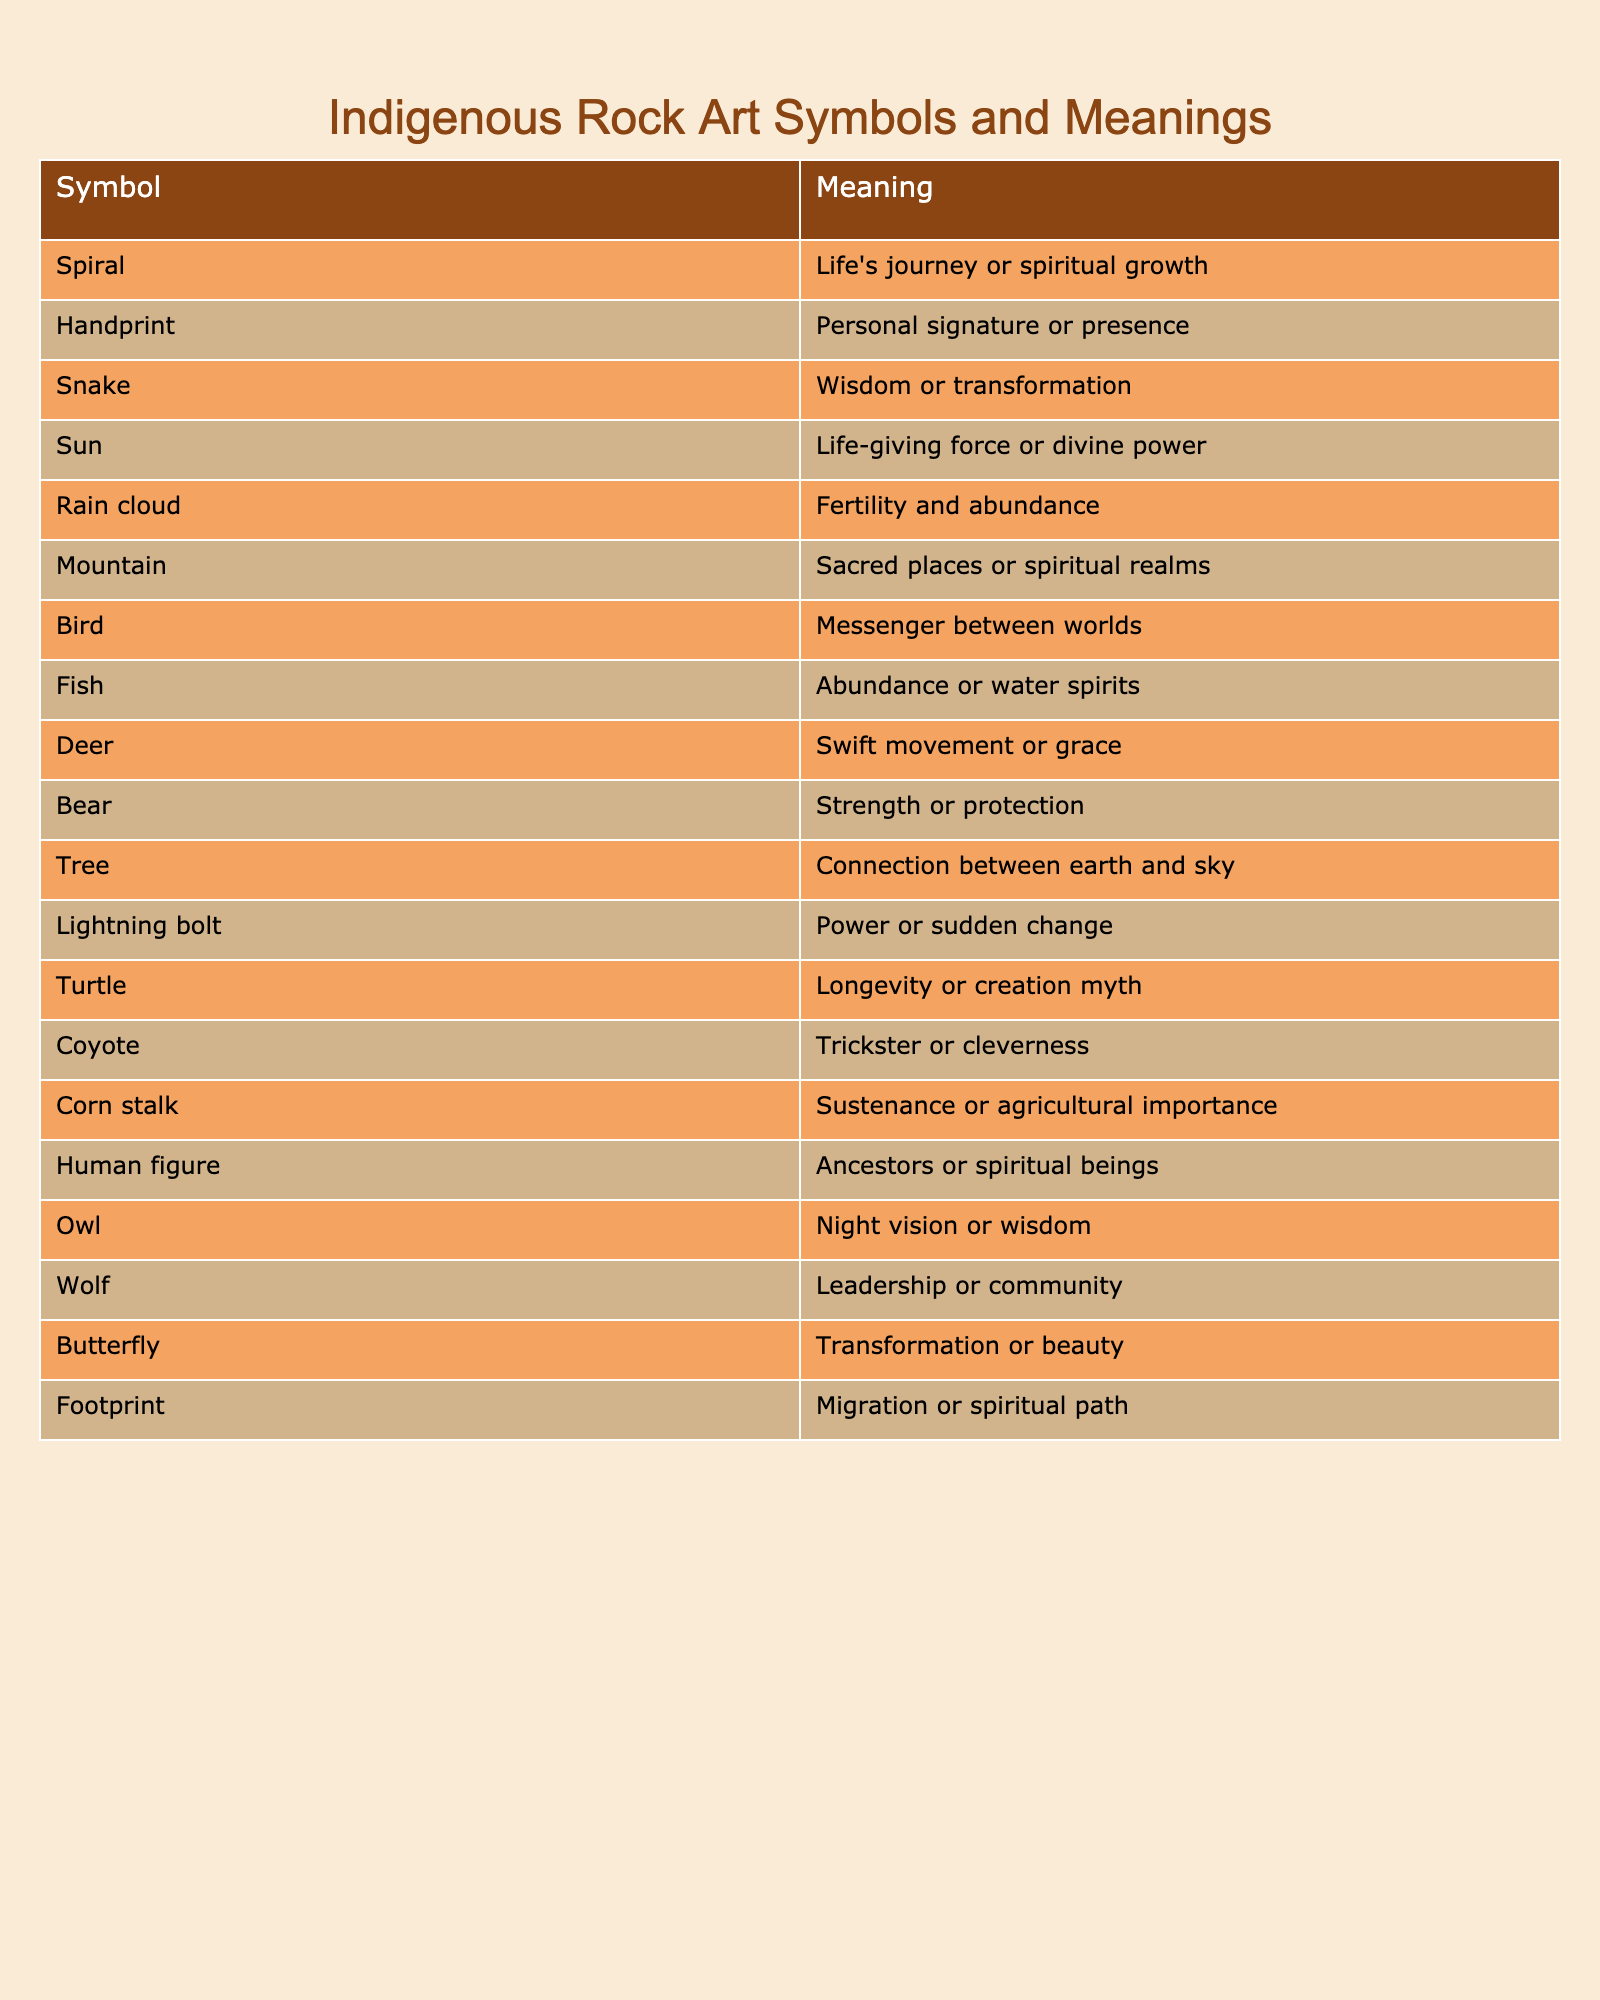What does the spiral symbolize in indigenous rock art? The table states that the spiral represents life's journey or spiritual growth. This is a direct retrieval from the symbol's meaning provided in the table.
Answer: Life's journey or spiritual growth What represents strength in the listed symbols? According to the table, the bear symbolizes strength or protection, and it can be found directly by looking at the symbols in the table.
Answer: Bear Is the handprint associated with personal expression? The table indicates that the handprint represents a personal signature or presence. Thus, the statement can be confirmed as true from the meaning.
Answer: Yes How many symbols in the table are related to transformation? The symbols related to transformation are the snake and the butterfly. Both meanings directly indicate transformation, which gives a total of two symbols.
Answer: 2 Which symbol represents a messenger between worlds? The table shows that the bird is recognized as a messenger between worlds, which can be easily identified through the symbols listed.
Answer: Bird Does the table show that the tree represents a connection between various realms? The meaning provided for the tree indicates it represents connection between earth and sky, confirming that it does symbolize a connection.
Answer: Yes What is the combined significance of the deer and the wolf? The deer represents swift movement or grace, and the wolf symbolizes leadership or community. Thus, when combined, they signify not only grace and movement but also the importance of community and leadership in indigenous beliefs.
Answer: Swift movement, grace, leadership, community Which symbol signifies abundance and also relates to water spirits? The table specifies that the fish symbolizes abundance or water spirits, allowing for a straightforward answer.
Answer: Fish Among all the symbols, which one links to longevity or creation myths? The turtle is indicated in the table as representing longevity or creation myth, making it the right choice based on the data presented.
Answer: Turtle 